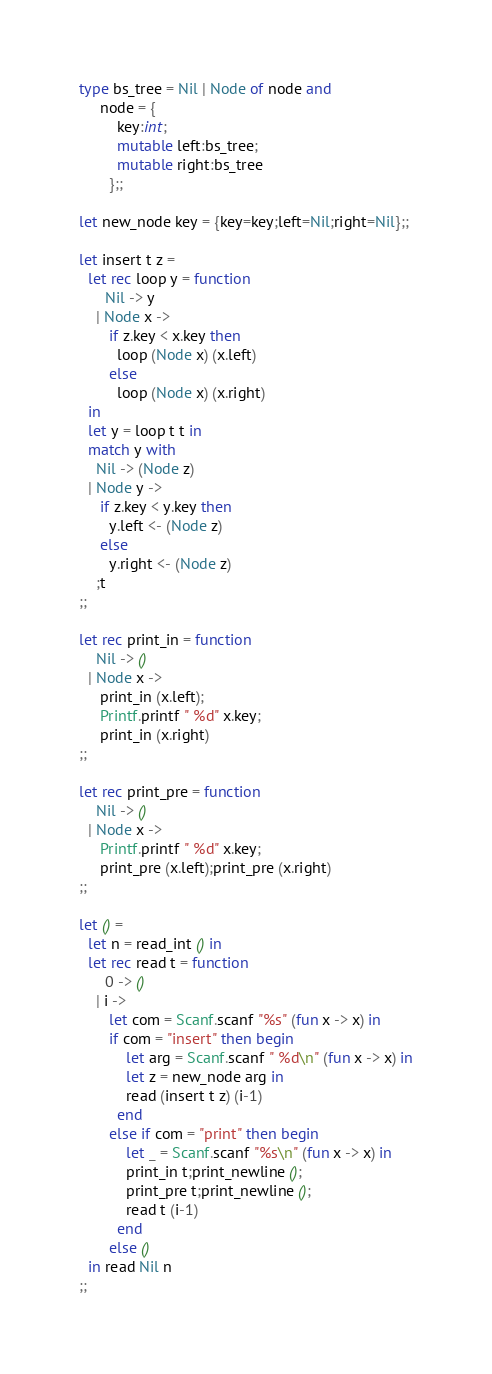Convert code to text. <code><loc_0><loc_0><loc_500><loc_500><_OCaml_>type bs_tree = Nil | Node of node and
     node = {
         key:int;
         mutable left:bs_tree;
         mutable right:bs_tree
       };;

let new_node key = {key=key;left=Nil;right=Nil};;

let insert t z =
  let rec loop y = function
      Nil -> y
    | Node x ->
       if z.key < x.key then
         loop (Node x) (x.left)
       else
         loop (Node x) (x.right)
  in
  let y = loop t t in
  match y with
    Nil -> (Node z)
  | Node y ->
     if z.key < y.key then
       y.left <- (Node z)
     else
       y.right <- (Node z)
    ;t
;;

let rec print_in = function
    Nil -> ()
  | Node x ->
     print_in (x.left);
     Printf.printf " %d" x.key;
     print_in (x.right)
;;

let rec print_pre = function
    Nil -> ()
  | Node x ->
     Printf.printf " %d" x.key;
     print_pre (x.left);print_pre (x.right)
;;

let () =
  let n = read_int () in
  let rec read t = function
      0 -> ()
    | i ->
       let com = Scanf.scanf "%s" (fun x -> x) in
       if com = "insert" then begin
           let arg = Scanf.scanf " %d\n" (fun x -> x) in
           let z = new_node arg in
           read (insert t z) (i-1)
         end
       else if com = "print" then begin
           let _ = Scanf.scanf "%s\n" (fun x -> x) in
           print_in t;print_newline ();
           print_pre t;print_newline ();
           read t (i-1)
         end
       else ()
  in read Nil n
;;</code> 